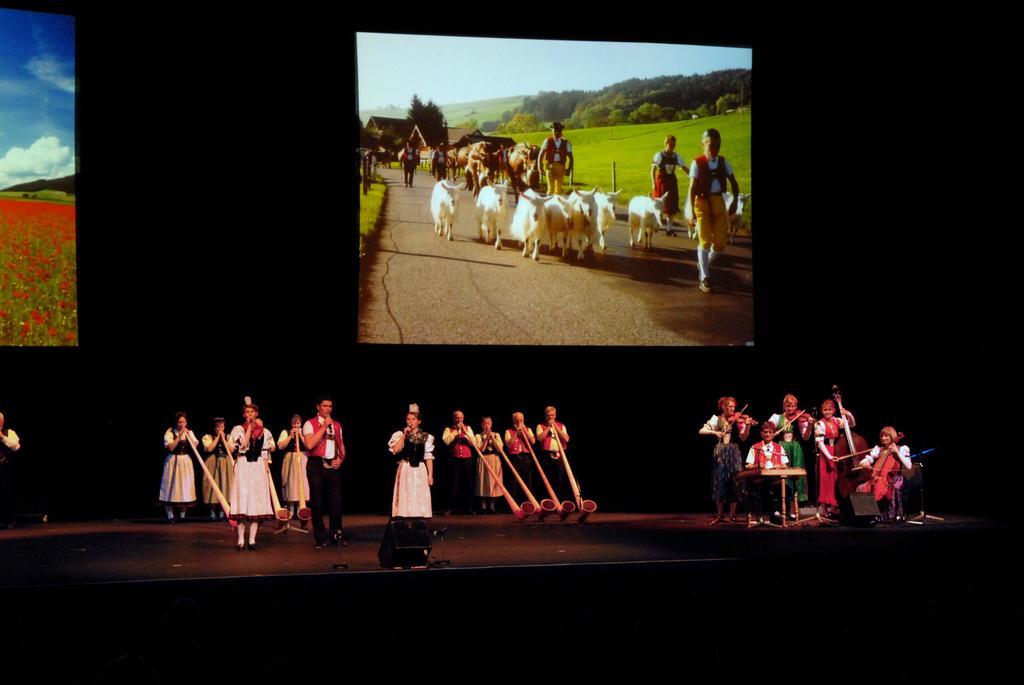Please provide a concise description of this image. In this picture there are people in the center of the image, on a stage and there are posters in the background area of the image. 